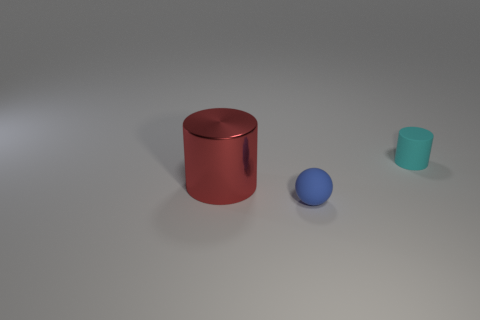Add 3 small objects. How many objects exist? 6 Subtract all cylinders. How many objects are left? 1 Add 1 large blue rubber blocks. How many large blue rubber blocks exist? 1 Subtract 0 green spheres. How many objects are left? 3 Subtract all red shiny objects. Subtract all gray metallic cubes. How many objects are left? 2 Add 1 tiny cyan things. How many tiny cyan things are left? 2 